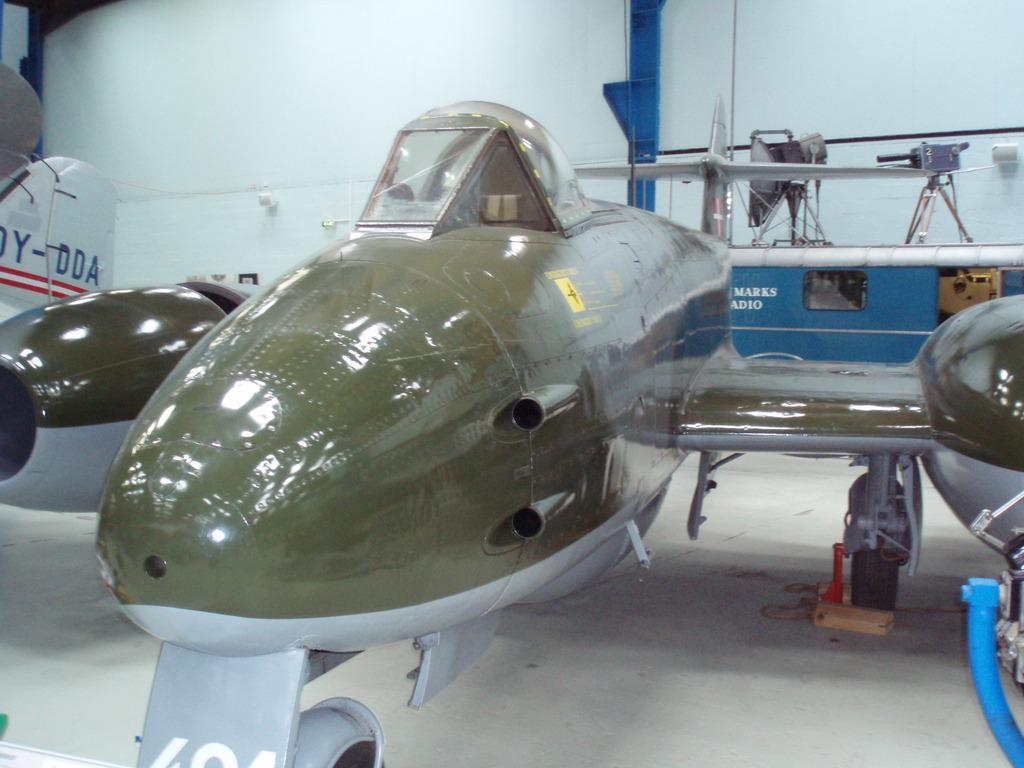<image>
Offer a succinct explanation of the picture presented. The ending serial number of the white plane is DDA. 